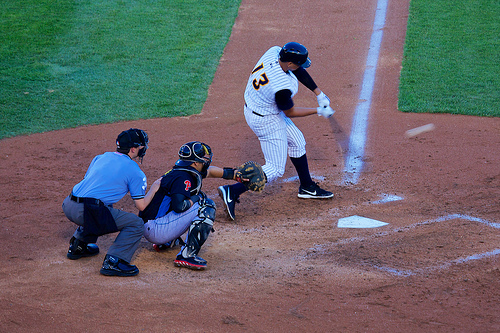Is the person to the left of the catcher wearing a shoe? Yes, the umpire to the left of the catcher is indeed wearing shoes, suitable for their role and activity. 